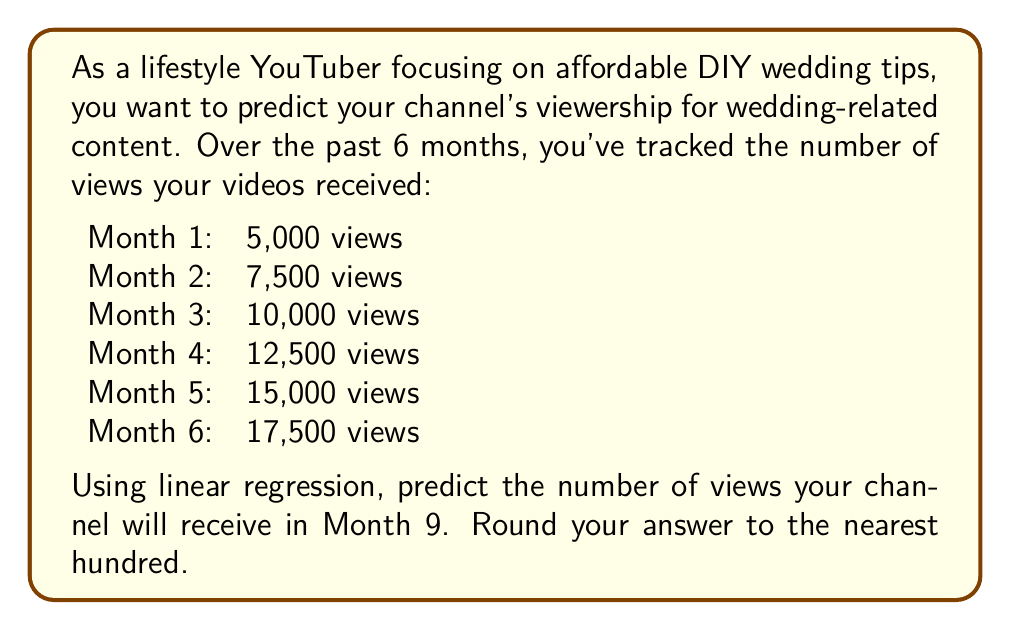Could you help me with this problem? To solve this problem using linear regression, we'll follow these steps:

1. Set up the linear equation: $y = mx + b$
   Where $y$ is the number of views, $m$ is the slope, $x$ is the month number, and $b$ is the y-intercept.

2. Calculate the slope $m$ using the formula:
   $$m = \frac{n\sum xy - \sum x \sum y}{n\sum x^2 - (\sum x)^2}$$

3. Calculate the y-intercept $b$ using the formula:
   $$b = \frac{\sum y - m\sum x}{n}$$

4. Use the resulting equation to predict views for Month 9.

Step 1: Prepare the data
x (month): 1, 2, 3, 4, 5, 6
y (views): 5000, 7500, 10000, 12500, 15000, 17500

Step 2: Calculate the slope $m$
$$\begin{align*}
n &= 6 \\
\sum x &= 21 \\
\sum y &= 67500 \\
\sum xy &= 307500 \\
\sum x^2 &= 91
\end{align*}$$

$$\begin{align*}
m &= \frac{6(307500) - (21)(67500)}{6(91) - (21)^2} \\
&= \frac{1845000 - 1417500}{546 - 441} \\
&= \frac{427500}{105} \\
&= 2500
\end{align*}$$

Step 3: Calculate the y-intercept $b$
$$\begin{align*}
b &= \frac{67500 - 2500(21)}{6} \\
&= \frac{67500 - 52500}{6} \\
&= \frac{15000}{6} \\
&= 2500
\end{align*}$$

Step 4: Form the linear equation
$y = 2500x + 2500$

Step 5: Predict views for Month 9
$$\begin{align*}
y &= 2500(9) + 2500 \\
&= 22500 + 2500 \\
&= 25000
\end{align*}$$

Therefore, the predicted number of views for Month 9 is 25,000.
Answer: 25,000 views 